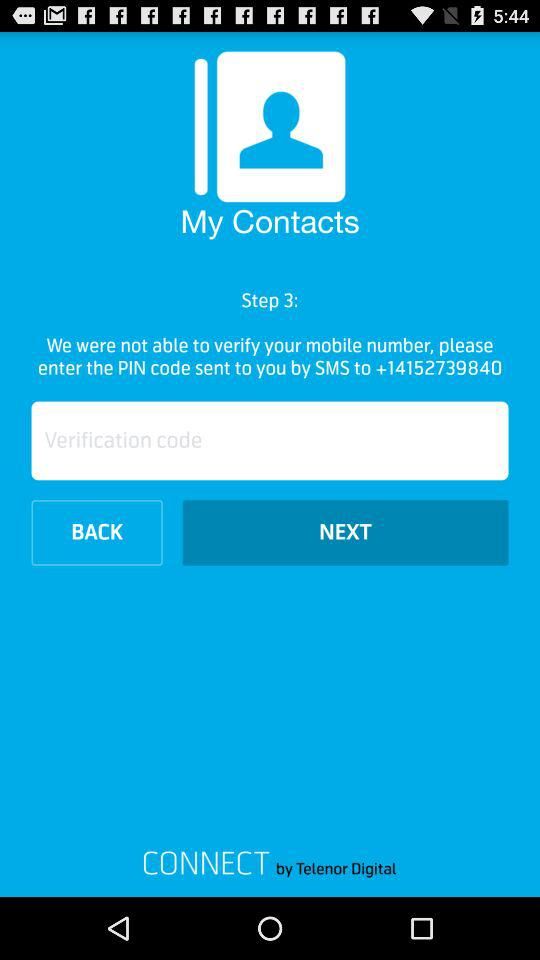What is the contact number? The contact number is +14152739840. 